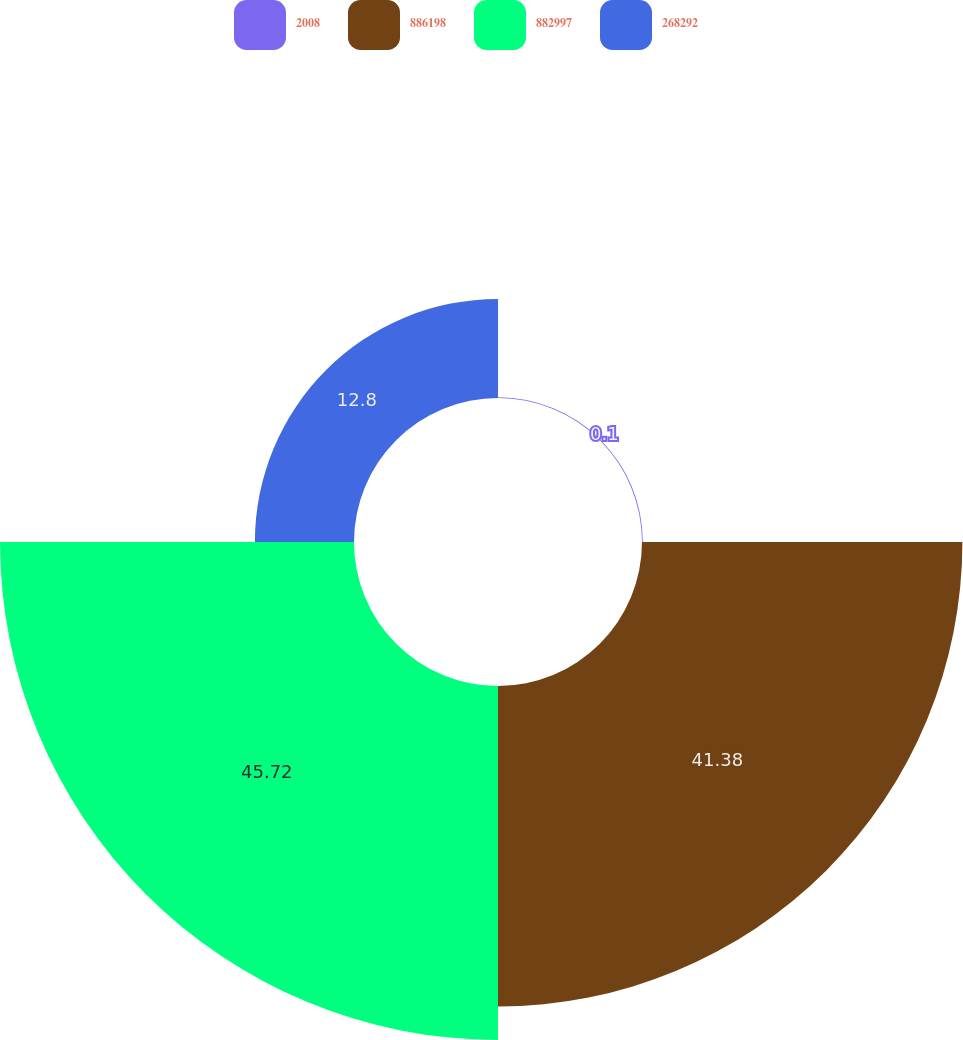Convert chart to OTSL. <chart><loc_0><loc_0><loc_500><loc_500><pie_chart><fcel>2008<fcel>886198<fcel>882997<fcel>268292<nl><fcel>0.1%<fcel>41.38%<fcel>45.72%<fcel>12.8%<nl></chart> 